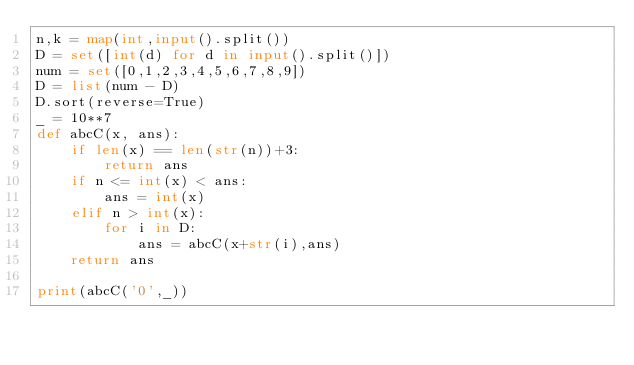Convert code to text. <code><loc_0><loc_0><loc_500><loc_500><_Python_>n,k = map(int,input().split())
D = set([int(d) for d in input().split()])
num = set([0,1,2,3,4,5,6,7,8,9])
D = list(num - D)
D.sort(reverse=True)
_ = 10**7
def abcC(x, ans):
    if len(x) == len(str(n))+3:
        return ans
    if n <= int(x) < ans:
        ans = int(x)
    elif n > int(x):
        for i in D:
            ans = abcC(x+str(i),ans)
    return ans
        
print(abcC('0',_))</code> 